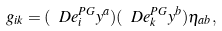<formula> <loc_0><loc_0><loc_500><loc_500>g _ { i k } = ( \ D e ^ { P G } _ { i } y ^ { a } ) ( \ D e ^ { P G } _ { k } y ^ { b } ) \eta _ { a b } ,</formula> 